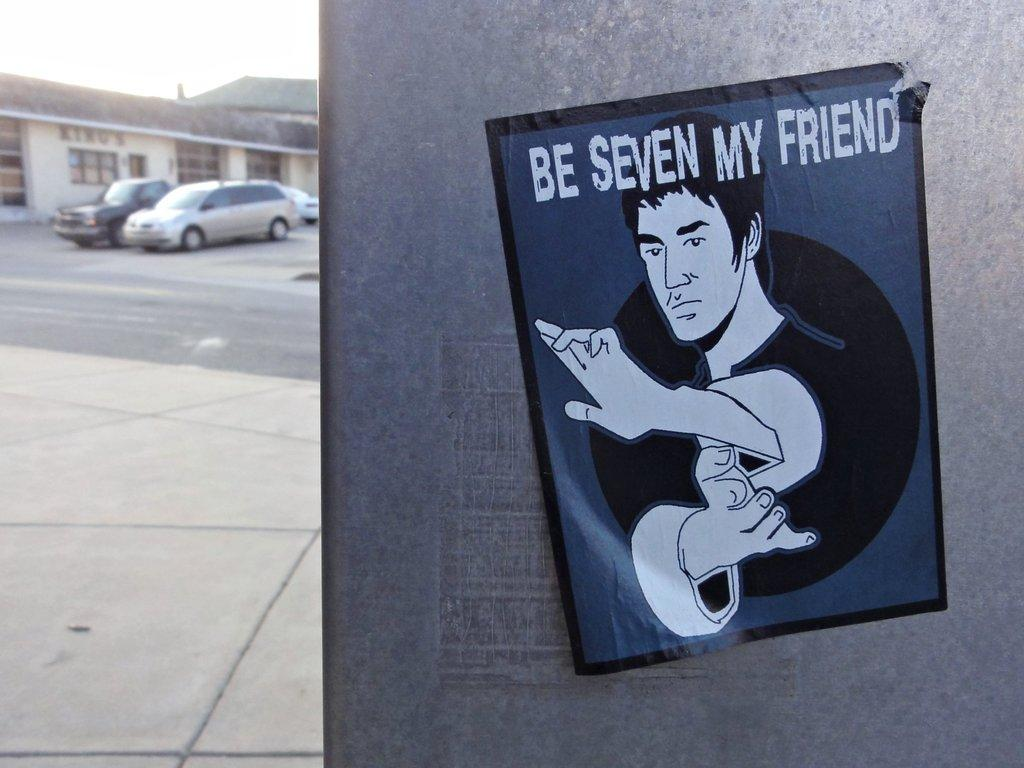What is the main subject in the center of the image? There is a poster in the center of the image. Where is the poster located? The poster is on a wall. What can be seen in the background of the image? Cars, buildings, and the sky are visible in the background of the image. What type of health advice is given by the kitty on the poster? There is no kitty present on the poster; it is a poster without any animals. 